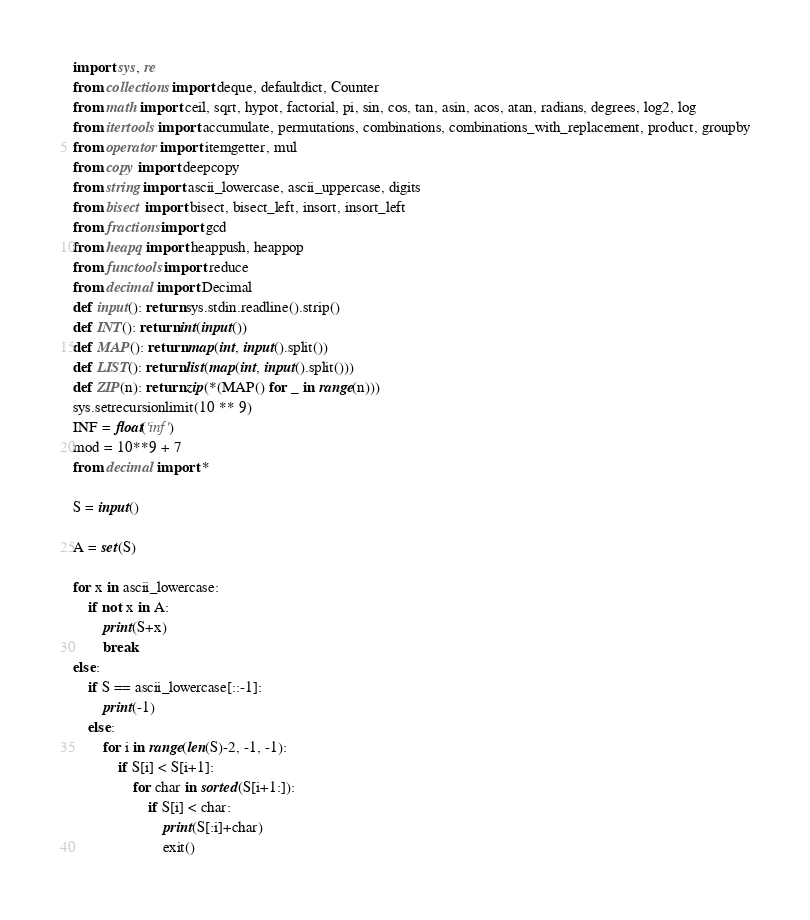Convert code to text. <code><loc_0><loc_0><loc_500><loc_500><_Python_>import sys, re
from collections import deque, defaultdict, Counter
from math import ceil, sqrt, hypot, factorial, pi, sin, cos, tan, asin, acos, atan, radians, degrees, log2, log
from itertools import accumulate, permutations, combinations, combinations_with_replacement, product, groupby
from operator import itemgetter, mul
from copy import deepcopy
from string import ascii_lowercase, ascii_uppercase, digits
from bisect import bisect, bisect_left, insort, insort_left
from fractions import gcd
from heapq import heappush, heappop
from functools import reduce
from decimal import Decimal
def input(): return sys.stdin.readline().strip()
def INT(): return int(input())
def MAP(): return map(int, input().split())
def LIST(): return list(map(int, input().split()))
def ZIP(n): return zip(*(MAP() for _ in range(n)))
sys.setrecursionlimit(10 ** 9)
INF = float('inf')
mod = 10**9 + 7
from decimal import *

S = input()

A = set(S)

for x in ascii_lowercase:
	if not x in A:
		print(S+x)
		break
else:
	if S == ascii_lowercase[::-1]:
		print(-1)
	else:
		for i in range(len(S)-2, -1, -1):
			if S[i] < S[i+1]:
				for char in sorted(S[i+1:]):
					if S[i] < char:
						print(S[:i]+char)
						exit()
</code> 